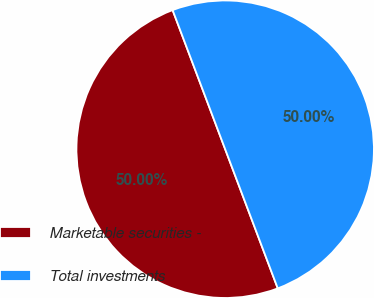<chart> <loc_0><loc_0><loc_500><loc_500><pie_chart><fcel>Marketable securities -<fcel>Total investments<nl><fcel>50.0%<fcel>50.0%<nl></chart> 